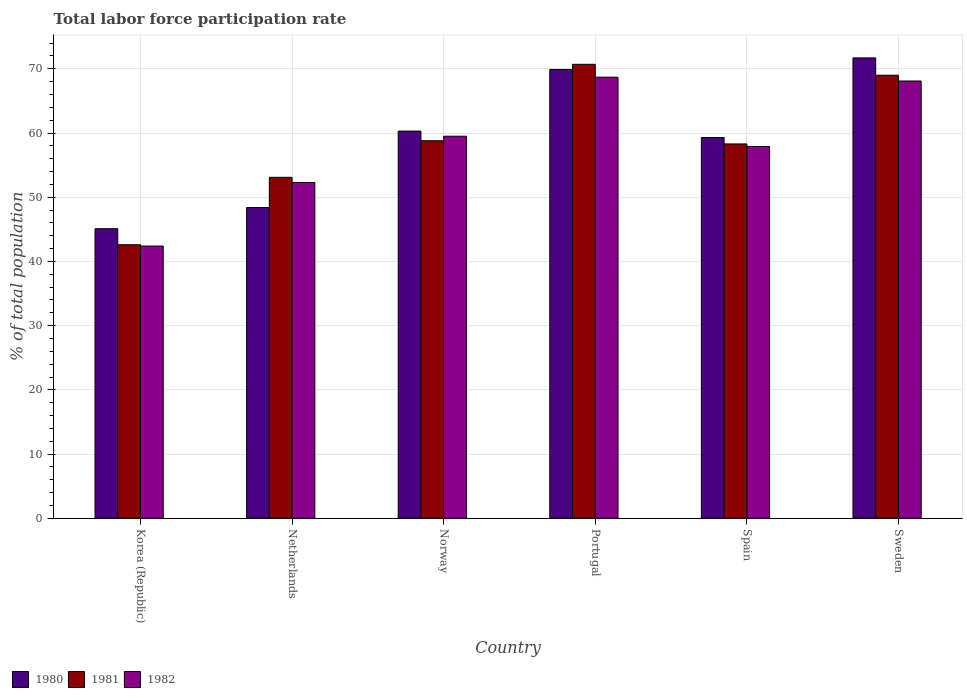How many different coloured bars are there?
Provide a succinct answer. 3. How many groups of bars are there?
Ensure brevity in your answer.  6. Are the number of bars per tick equal to the number of legend labels?
Make the answer very short. Yes. Are the number of bars on each tick of the X-axis equal?
Your response must be concise. Yes. How many bars are there on the 4th tick from the left?
Ensure brevity in your answer.  3. What is the label of the 4th group of bars from the left?
Keep it short and to the point. Portugal. In how many cases, is the number of bars for a given country not equal to the number of legend labels?
Keep it short and to the point. 0. Across all countries, what is the maximum total labor force participation rate in 1982?
Make the answer very short. 68.7. Across all countries, what is the minimum total labor force participation rate in 1982?
Your answer should be compact. 42.4. In which country was the total labor force participation rate in 1980 maximum?
Give a very brief answer. Sweden. What is the total total labor force participation rate in 1980 in the graph?
Provide a short and direct response. 354.7. What is the difference between the total labor force participation rate in 1980 in Netherlands and that in Sweden?
Provide a short and direct response. -23.3. What is the difference between the total labor force participation rate in 1980 in Korea (Republic) and the total labor force participation rate in 1982 in Sweden?
Ensure brevity in your answer.  -23. What is the average total labor force participation rate in 1982 per country?
Offer a terse response. 58.15. What is the difference between the total labor force participation rate of/in 1981 and total labor force participation rate of/in 1980 in Norway?
Ensure brevity in your answer.  -1.5. What is the ratio of the total labor force participation rate in 1982 in Korea (Republic) to that in Spain?
Keep it short and to the point. 0.73. What is the difference between the highest and the second highest total labor force participation rate in 1981?
Offer a very short reply. -10.2. What is the difference between the highest and the lowest total labor force participation rate in 1981?
Make the answer very short. 28.1. In how many countries, is the total labor force participation rate in 1981 greater than the average total labor force participation rate in 1981 taken over all countries?
Your response must be concise. 3. Is the sum of the total labor force participation rate in 1980 in Netherlands and Portugal greater than the maximum total labor force participation rate in 1981 across all countries?
Offer a very short reply. Yes. What does the 2nd bar from the left in Spain represents?
Make the answer very short. 1981. Is it the case that in every country, the sum of the total labor force participation rate in 1980 and total labor force participation rate in 1982 is greater than the total labor force participation rate in 1981?
Keep it short and to the point. Yes. How many bars are there?
Your response must be concise. 18. Are all the bars in the graph horizontal?
Provide a short and direct response. No. How many countries are there in the graph?
Provide a succinct answer. 6. What is the difference between two consecutive major ticks on the Y-axis?
Your answer should be very brief. 10. Does the graph contain any zero values?
Offer a very short reply. No. How many legend labels are there?
Keep it short and to the point. 3. How are the legend labels stacked?
Make the answer very short. Horizontal. What is the title of the graph?
Provide a succinct answer. Total labor force participation rate. Does "1968" appear as one of the legend labels in the graph?
Provide a succinct answer. No. What is the label or title of the X-axis?
Offer a very short reply. Country. What is the label or title of the Y-axis?
Make the answer very short. % of total population. What is the % of total population in 1980 in Korea (Republic)?
Provide a short and direct response. 45.1. What is the % of total population in 1981 in Korea (Republic)?
Provide a succinct answer. 42.6. What is the % of total population in 1982 in Korea (Republic)?
Provide a succinct answer. 42.4. What is the % of total population in 1980 in Netherlands?
Offer a very short reply. 48.4. What is the % of total population of 1981 in Netherlands?
Provide a succinct answer. 53.1. What is the % of total population in 1982 in Netherlands?
Provide a succinct answer. 52.3. What is the % of total population of 1980 in Norway?
Your answer should be compact. 60.3. What is the % of total population of 1981 in Norway?
Ensure brevity in your answer.  58.8. What is the % of total population of 1982 in Norway?
Your answer should be very brief. 59.5. What is the % of total population of 1980 in Portugal?
Offer a terse response. 69.9. What is the % of total population in 1981 in Portugal?
Your answer should be compact. 70.7. What is the % of total population of 1982 in Portugal?
Provide a succinct answer. 68.7. What is the % of total population of 1980 in Spain?
Provide a short and direct response. 59.3. What is the % of total population of 1981 in Spain?
Ensure brevity in your answer.  58.3. What is the % of total population in 1982 in Spain?
Keep it short and to the point. 57.9. What is the % of total population in 1980 in Sweden?
Offer a very short reply. 71.7. What is the % of total population in 1982 in Sweden?
Your answer should be compact. 68.1. Across all countries, what is the maximum % of total population in 1980?
Keep it short and to the point. 71.7. Across all countries, what is the maximum % of total population in 1981?
Keep it short and to the point. 70.7. Across all countries, what is the maximum % of total population of 1982?
Keep it short and to the point. 68.7. Across all countries, what is the minimum % of total population in 1980?
Your response must be concise. 45.1. Across all countries, what is the minimum % of total population of 1981?
Make the answer very short. 42.6. Across all countries, what is the minimum % of total population of 1982?
Keep it short and to the point. 42.4. What is the total % of total population of 1980 in the graph?
Offer a very short reply. 354.7. What is the total % of total population of 1981 in the graph?
Your answer should be very brief. 352.5. What is the total % of total population in 1982 in the graph?
Provide a short and direct response. 348.9. What is the difference between the % of total population in 1980 in Korea (Republic) and that in Netherlands?
Keep it short and to the point. -3.3. What is the difference between the % of total population in 1980 in Korea (Republic) and that in Norway?
Offer a terse response. -15.2. What is the difference between the % of total population of 1981 in Korea (Republic) and that in Norway?
Make the answer very short. -16.2. What is the difference between the % of total population in 1982 in Korea (Republic) and that in Norway?
Provide a succinct answer. -17.1. What is the difference between the % of total population in 1980 in Korea (Republic) and that in Portugal?
Your answer should be compact. -24.8. What is the difference between the % of total population in 1981 in Korea (Republic) and that in Portugal?
Give a very brief answer. -28.1. What is the difference between the % of total population in 1982 in Korea (Republic) and that in Portugal?
Ensure brevity in your answer.  -26.3. What is the difference between the % of total population in 1981 in Korea (Republic) and that in Spain?
Offer a terse response. -15.7. What is the difference between the % of total population in 1982 in Korea (Republic) and that in Spain?
Keep it short and to the point. -15.5. What is the difference between the % of total population of 1980 in Korea (Republic) and that in Sweden?
Give a very brief answer. -26.6. What is the difference between the % of total population of 1981 in Korea (Republic) and that in Sweden?
Ensure brevity in your answer.  -26.4. What is the difference between the % of total population of 1982 in Korea (Republic) and that in Sweden?
Ensure brevity in your answer.  -25.7. What is the difference between the % of total population of 1981 in Netherlands and that in Norway?
Provide a succinct answer. -5.7. What is the difference between the % of total population of 1980 in Netherlands and that in Portugal?
Your response must be concise. -21.5. What is the difference between the % of total population of 1981 in Netherlands and that in Portugal?
Provide a short and direct response. -17.6. What is the difference between the % of total population in 1982 in Netherlands and that in Portugal?
Provide a short and direct response. -16.4. What is the difference between the % of total population of 1980 in Netherlands and that in Spain?
Make the answer very short. -10.9. What is the difference between the % of total population of 1982 in Netherlands and that in Spain?
Offer a terse response. -5.6. What is the difference between the % of total population of 1980 in Netherlands and that in Sweden?
Ensure brevity in your answer.  -23.3. What is the difference between the % of total population of 1981 in Netherlands and that in Sweden?
Offer a very short reply. -15.9. What is the difference between the % of total population of 1982 in Netherlands and that in Sweden?
Your answer should be compact. -15.8. What is the difference between the % of total population of 1981 in Norway and that in Portugal?
Your answer should be very brief. -11.9. What is the difference between the % of total population of 1982 in Norway and that in Portugal?
Your answer should be very brief. -9.2. What is the difference between the % of total population in 1981 in Norway and that in Spain?
Make the answer very short. 0.5. What is the difference between the % of total population of 1980 in Norway and that in Sweden?
Provide a succinct answer. -11.4. What is the difference between the % of total population of 1981 in Norway and that in Sweden?
Ensure brevity in your answer.  -10.2. What is the difference between the % of total population of 1982 in Norway and that in Sweden?
Provide a succinct answer. -8.6. What is the difference between the % of total population in 1981 in Spain and that in Sweden?
Make the answer very short. -10.7. What is the difference between the % of total population in 1982 in Spain and that in Sweden?
Offer a terse response. -10.2. What is the difference between the % of total population of 1980 in Korea (Republic) and the % of total population of 1981 in Netherlands?
Provide a short and direct response. -8. What is the difference between the % of total population in 1980 in Korea (Republic) and the % of total population in 1982 in Netherlands?
Your response must be concise. -7.2. What is the difference between the % of total population of 1981 in Korea (Republic) and the % of total population of 1982 in Netherlands?
Your answer should be very brief. -9.7. What is the difference between the % of total population of 1980 in Korea (Republic) and the % of total population of 1981 in Norway?
Give a very brief answer. -13.7. What is the difference between the % of total population in 1980 in Korea (Republic) and the % of total population in 1982 in Norway?
Provide a succinct answer. -14.4. What is the difference between the % of total population of 1981 in Korea (Republic) and the % of total population of 1982 in Norway?
Provide a succinct answer. -16.9. What is the difference between the % of total population of 1980 in Korea (Republic) and the % of total population of 1981 in Portugal?
Offer a very short reply. -25.6. What is the difference between the % of total population in 1980 in Korea (Republic) and the % of total population in 1982 in Portugal?
Ensure brevity in your answer.  -23.6. What is the difference between the % of total population in 1981 in Korea (Republic) and the % of total population in 1982 in Portugal?
Offer a terse response. -26.1. What is the difference between the % of total population of 1980 in Korea (Republic) and the % of total population of 1982 in Spain?
Offer a very short reply. -12.8. What is the difference between the % of total population of 1981 in Korea (Republic) and the % of total population of 1982 in Spain?
Make the answer very short. -15.3. What is the difference between the % of total population of 1980 in Korea (Republic) and the % of total population of 1981 in Sweden?
Offer a terse response. -23.9. What is the difference between the % of total population of 1980 in Korea (Republic) and the % of total population of 1982 in Sweden?
Provide a short and direct response. -23. What is the difference between the % of total population in 1981 in Korea (Republic) and the % of total population in 1982 in Sweden?
Your answer should be very brief. -25.5. What is the difference between the % of total population of 1980 in Netherlands and the % of total population of 1981 in Norway?
Offer a very short reply. -10.4. What is the difference between the % of total population of 1980 in Netherlands and the % of total population of 1982 in Norway?
Make the answer very short. -11.1. What is the difference between the % of total population of 1980 in Netherlands and the % of total population of 1981 in Portugal?
Provide a short and direct response. -22.3. What is the difference between the % of total population of 1980 in Netherlands and the % of total population of 1982 in Portugal?
Ensure brevity in your answer.  -20.3. What is the difference between the % of total population in 1981 in Netherlands and the % of total population in 1982 in Portugal?
Keep it short and to the point. -15.6. What is the difference between the % of total population of 1980 in Netherlands and the % of total population of 1981 in Sweden?
Provide a succinct answer. -20.6. What is the difference between the % of total population of 1980 in Netherlands and the % of total population of 1982 in Sweden?
Keep it short and to the point. -19.7. What is the difference between the % of total population in 1981 in Netherlands and the % of total population in 1982 in Sweden?
Offer a terse response. -15. What is the difference between the % of total population in 1980 in Norway and the % of total population in 1982 in Spain?
Provide a short and direct response. 2.4. What is the difference between the % of total population in 1981 in Norway and the % of total population in 1982 in Spain?
Provide a short and direct response. 0.9. What is the difference between the % of total population in 1981 in Norway and the % of total population in 1982 in Sweden?
Give a very brief answer. -9.3. What is the difference between the % of total population of 1980 in Portugal and the % of total population of 1982 in Spain?
Your response must be concise. 12. What is the difference between the % of total population of 1981 in Portugal and the % of total population of 1982 in Sweden?
Your answer should be compact. 2.6. What is the difference between the % of total population of 1980 in Spain and the % of total population of 1981 in Sweden?
Your answer should be compact. -9.7. What is the difference between the % of total population of 1980 in Spain and the % of total population of 1982 in Sweden?
Ensure brevity in your answer.  -8.8. What is the average % of total population in 1980 per country?
Ensure brevity in your answer.  59.12. What is the average % of total population in 1981 per country?
Keep it short and to the point. 58.75. What is the average % of total population in 1982 per country?
Offer a very short reply. 58.15. What is the difference between the % of total population of 1980 and % of total population of 1982 in Korea (Republic)?
Give a very brief answer. 2.7. What is the difference between the % of total population in 1980 and % of total population in 1982 in Netherlands?
Keep it short and to the point. -3.9. What is the difference between the % of total population in 1981 and % of total population in 1982 in Netherlands?
Provide a short and direct response. 0.8. What is the difference between the % of total population of 1980 and % of total population of 1981 in Norway?
Offer a terse response. 1.5. What is the difference between the % of total population in 1980 and % of total population in 1982 in Norway?
Your answer should be compact. 0.8. What is the difference between the % of total population of 1981 and % of total population of 1982 in Norway?
Offer a very short reply. -0.7. What is the difference between the % of total population in 1980 and % of total population in 1982 in Spain?
Ensure brevity in your answer.  1.4. What is the difference between the % of total population in 1980 and % of total population in 1982 in Sweden?
Provide a succinct answer. 3.6. What is the ratio of the % of total population in 1980 in Korea (Republic) to that in Netherlands?
Offer a very short reply. 0.93. What is the ratio of the % of total population of 1981 in Korea (Republic) to that in Netherlands?
Your answer should be very brief. 0.8. What is the ratio of the % of total population of 1982 in Korea (Republic) to that in Netherlands?
Provide a short and direct response. 0.81. What is the ratio of the % of total population of 1980 in Korea (Republic) to that in Norway?
Offer a very short reply. 0.75. What is the ratio of the % of total population of 1981 in Korea (Republic) to that in Norway?
Make the answer very short. 0.72. What is the ratio of the % of total population of 1982 in Korea (Republic) to that in Norway?
Provide a succinct answer. 0.71. What is the ratio of the % of total population in 1980 in Korea (Republic) to that in Portugal?
Give a very brief answer. 0.65. What is the ratio of the % of total population of 1981 in Korea (Republic) to that in Portugal?
Keep it short and to the point. 0.6. What is the ratio of the % of total population of 1982 in Korea (Republic) to that in Portugal?
Provide a succinct answer. 0.62. What is the ratio of the % of total population of 1980 in Korea (Republic) to that in Spain?
Offer a terse response. 0.76. What is the ratio of the % of total population in 1981 in Korea (Republic) to that in Spain?
Your answer should be very brief. 0.73. What is the ratio of the % of total population of 1982 in Korea (Republic) to that in Spain?
Provide a short and direct response. 0.73. What is the ratio of the % of total population of 1980 in Korea (Republic) to that in Sweden?
Offer a terse response. 0.63. What is the ratio of the % of total population of 1981 in Korea (Republic) to that in Sweden?
Provide a short and direct response. 0.62. What is the ratio of the % of total population of 1982 in Korea (Republic) to that in Sweden?
Ensure brevity in your answer.  0.62. What is the ratio of the % of total population of 1980 in Netherlands to that in Norway?
Offer a very short reply. 0.8. What is the ratio of the % of total population in 1981 in Netherlands to that in Norway?
Give a very brief answer. 0.9. What is the ratio of the % of total population in 1982 in Netherlands to that in Norway?
Make the answer very short. 0.88. What is the ratio of the % of total population of 1980 in Netherlands to that in Portugal?
Your response must be concise. 0.69. What is the ratio of the % of total population of 1981 in Netherlands to that in Portugal?
Your answer should be compact. 0.75. What is the ratio of the % of total population of 1982 in Netherlands to that in Portugal?
Give a very brief answer. 0.76. What is the ratio of the % of total population of 1980 in Netherlands to that in Spain?
Offer a very short reply. 0.82. What is the ratio of the % of total population in 1981 in Netherlands to that in Spain?
Your answer should be very brief. 0.91. What is the ratio of the % of total population of 1982 in Netherlands to that in Spain?
Your answer should be very brief. 0.9. What is the ratio of the % of total population of 1980 in Netherlands to that in Sweden?
Your response must be concise. 0.68. What is the ratio of the % of total population in 1981 in Netherlands to that in Sweden?
Your answer should be very brief. 0.77. What is the ratio of the % of total population in 1982 in Netherlands to that in Sweden?
Give a very brief answer. 0.77. What is the ratio of the % of total population of 1980 in Norway to that in Portugal?
Provide a succinct answer. 0.86. What is the ratio of the % of total population of 1981 in Norway to that in Portugal?
Offer a very short reply. 0.83. What is the ratio of the % of total population in 1982 in Norway to that in Portugal?
Ensure brevity in your answer.  0.87. What is the ratio of the % of total population in 1980 in Norway to that in Spain?
Offer a very short reply. 1.02. What is the ratio of the % of total population in 1981 in Norway to that in Spain?
Your response must be concise. 1.01. What is the ratio of the % of total population of 1982 in Norway to that in Spain?
Ensure brevity in your answer.  1.03. What is the ratio of the % of total population of 1980 in Norway to that in Sweden?
Provide a short and direct response. 0.84. What is the ratio of the % of total population of 1981 in Norway to that in Sweden?
Provide a succinct answer. 0.85. What is the ratio of the % of total population in 1982 in Norway to that in Sweden?
Keep it short and to the point. 0.87. What is the ratio of the % of total population in 1980 in Portugal to that in Spain?
Offer a very short reply. 1.18. What is the ratio of the % of total population in 1981 in Portugal to that in Spain?
Your response must be concise. 1.21. What is the ratio of the % of total population in 1982 in Portugal to that in Spain?
Make the answer very short. 1.19. What is the ratio of the % of total population of 1980 in Portugal to that in Sweden?
Keep it short and to the point. 0.97. What is the ratio of the % of total population in 1981 in Portugal to that in Sweden?
Give a very brief answer. 1.02. What is the ratio of the % of total population of 1982 in Portugal to that in Sweden?
Your answer should be compact. 1.01. What is the ratio of the % of total population in 1980 in Spain to that in Sweden?
Offer a very short reply. 0.83. What is the ratio of the % of total population of 1981 in Spain to that in Sweden?
Ensure brevity in your answer.  0.84. What is the ratio of the % of total population in 1982 in Spain to that in Sweden?
Your response must be concise. 0.85. What is the difference between the highest and the second highest % of total population of 1981?
Ensure brevity in your answer.  1.7. What is the difference between the highest and the lowest % of total population in 1980?
Your response must be concise. 26.6. What is the difference between the highest and the lowest % of total population of 1981?
Make the answer very short. 28.1. What is the difference between the highest and the lowest % of total population in 1982?
Make the answer very short. 26.3. 